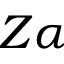<formula> <loc_0><loc_0><loc_500><loc_500>Z \alpha</formula> 